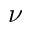<formula> <loc_0><loc_0><loc_500><loc_500>\nu</formula> 